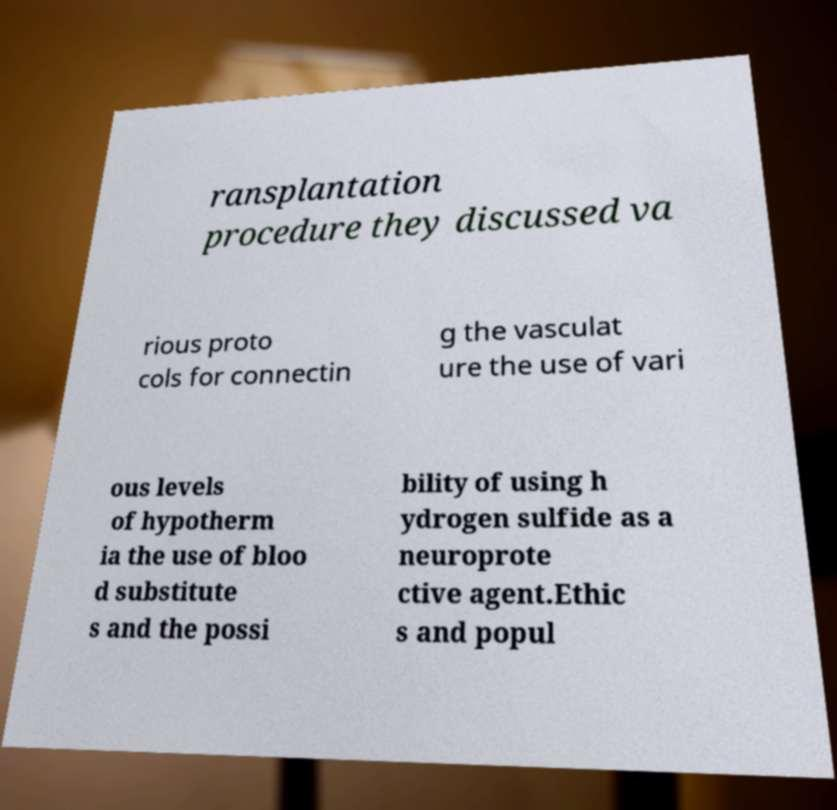I need the written content from this picture converted into text. Can you do that? ransplantation procedure they discussed va rious proto cols for connectin g the vasculat ure the use of vari ous levels of hypotherm ia the use of bloo d substitute s and the possi bility of using h ydrogen sulfide as a neuroprote ctive agent.Ethic s and popul 